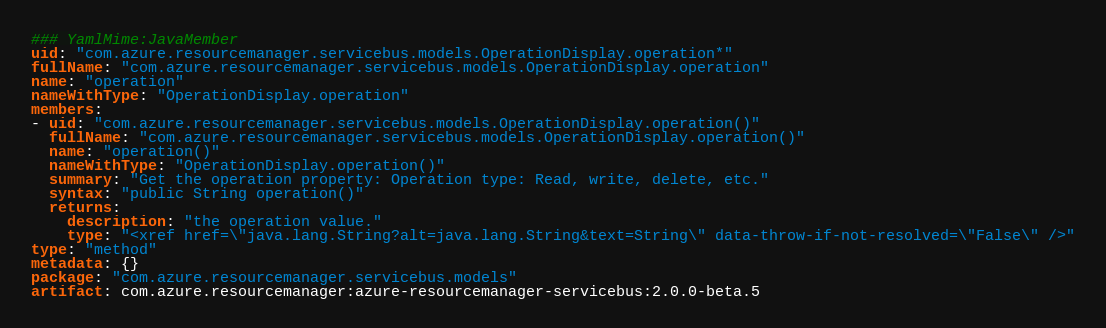<code> <loc_0><loc_0><loc_500><loc_500><_YAML_>### YamlMime:JavaMember
uid: "com.azure.resourcemanager.servicebus.models.OperationDisplay.operation*"
fullName: "com.azure.resourcemanager.servicebus.models.OperationDisplay.operation"
name: "operation"
nameWithType: "OperationDisplay.operation"
members:
- uid: "com.azure.resourcemanager.servicebus.models.OperationDisplay.operation()"
  fullName: "com.azure.resourcemanager.servicebus.models.OperationDisplay.operation()"
  name: "operation()"
  nameWithType: "OperationDisplay.operation()"
  summary: "Get the operation property: Operation type: Read, write, delete, etc."
  syntax: "public String operation()"
  returns:
    description: "the operation value."
    type: "<xref href=\"java.lang.String?alt=java.lang.String&text=String\" data-throw-if-not-resolved=\"False\" />"
type: "method"
metadata: {}
package: "com.azure.resourcemanager.servicebus.models"
artifact: com.azure.resourcemanager:azure-resourcemanager-servicebus:2.0.0-beta.5
</code> 